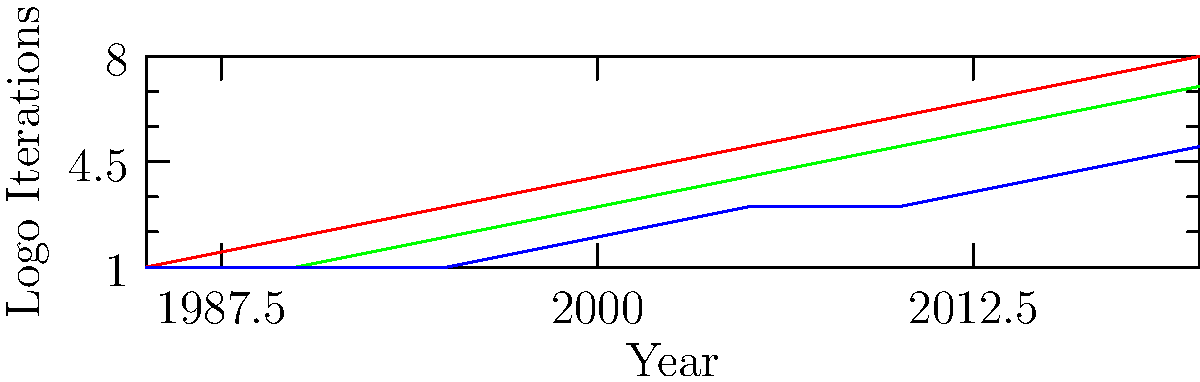Based on the graph showing the evolution of logo designs for three popular Nintendo franchises, which series has undergone the most logo iterations since 1985? To determine which series has undergone the most logo iterations since 1985, we need to analyze the graph for each franchise:

1. Mario (red line):
   - Starts at 1 in 1985
   - Ends at 8 in 2020
   - Total iterations: 8

2. Zelda (green line):
   - Starts at 1 in 1985
   - Ends at 7 in 2020
   - Total iterations: 7

3. Metroid (blue line):
   - Starts at 1 in 1985
   - Ends at 5 in 2020
   - Total iterations: 5

Comparing the final values in 2020:
- Mario: 8
- Zelda: 7
- Metroid: 5

Mario has the highest number of iterations at 8, indicating that it has undergone the most logo changes since 1985.
Answer: Mario 